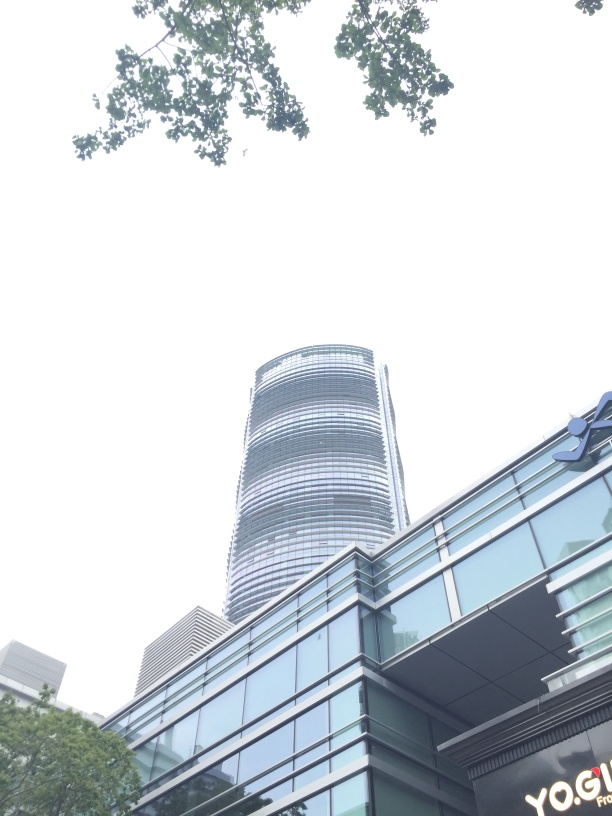Can you tell me what the architectural style of the building might be? The building in the image exhibits characteristics of modern architecture, particularly the use of glass and steel, a sleek silhouette, and the emphasis on vertical lines in its design. 